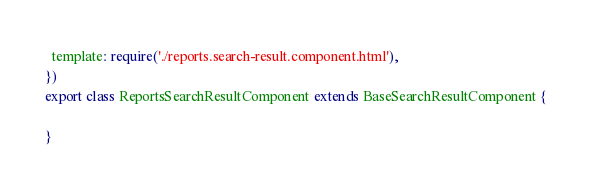<code> <loc_0><loc_0><loc_500><loc_500><_TypeScript_>  template: require('./reports.search-result.component.html'),
})
export class ReportsSearchResultComponent extends BaseSearchResultComponent {

}
</code> 